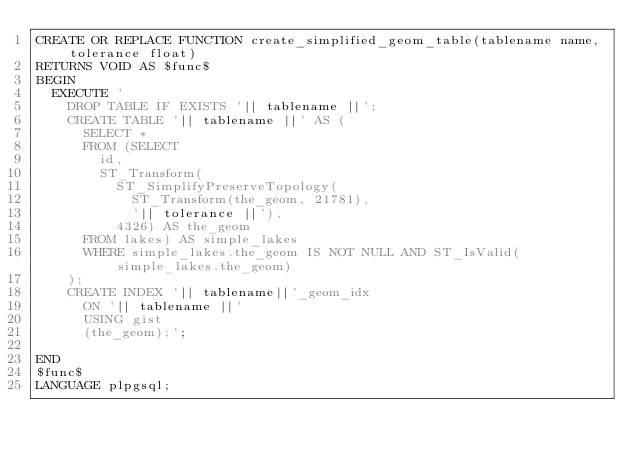<code> <loc_0><loc_0><loc_500><loc_500><_SQL_>CREATE OR REPLACE FUNCTION create_simplified_geom_table(tablename name, tolerance float)
RETURNS VOID AS $func$
BEGIN
  EXECUTE '
    DROP TABLE IF EXISTS '|| tablename ||';
    CREATE TABLE '|| tablename ||' AS (
      SELECT *
      FROM (SELECT 
        id, 
        ST_Transform(
          ST_SimplifyPreserveTopology(
            ST_Transform(the_geom, 21781),
            '|| tolerance ||'),
          4326) AS the_geom
      FROM lakes) AS simple_lakes
      WHERE simple_lakes.the_geom IS NOT NULL AND ST_IsValid(simple_lakes.the_geom)
    );
    CREATE INDEX '|| tablename||'_geom_idx
      ON '|| tablename ||'
      USING gist
      (the_geom);';
    
END
$func$
LANGUAGE plpgsql;
</code> 